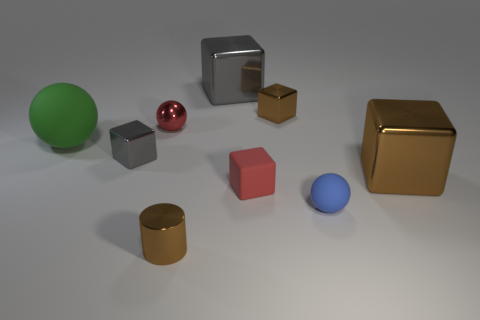Subtract 2 cubes. How many cubes are left? 3 Subtract all tiny red cubes. How many cubes are left? 4 Subtract all red cubes. How many cubes are left? 4 Subtract all green blocks. Subtract all red cylinders. How many blocks are left? 5 Add 1 balls. How many objects exist? 10 Subtract all blocks. How many objects are left? 4 Subtract all metal cylinders. Subtract all metallic cylinders. How many objects are left? 7 Add 5 tiny cubes. How many tiny cubes are left? 8 Add 5 tiny brown metallic things. How many tiny brown metallic things exist? 7 Subtract 2 brown cubes. How many objects are left? 7 